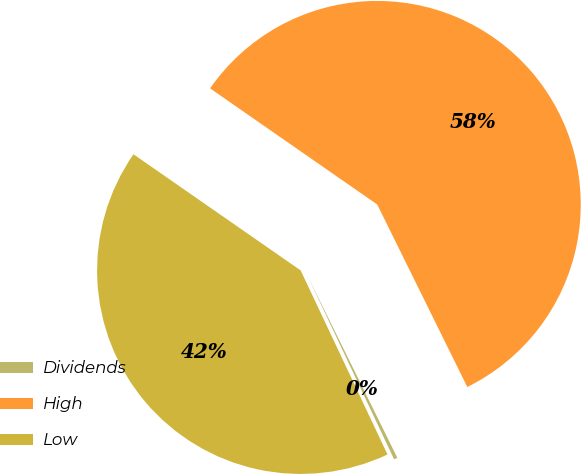Convert chart. <chart><loc_0><loc_0><loc_500><loc_500><pie_chart><fcel>Dividends<fcel>High<fcel>Low<nl><fcel>0.28%<fcel>58.04%<fcel>41.68%<nl></chart> 